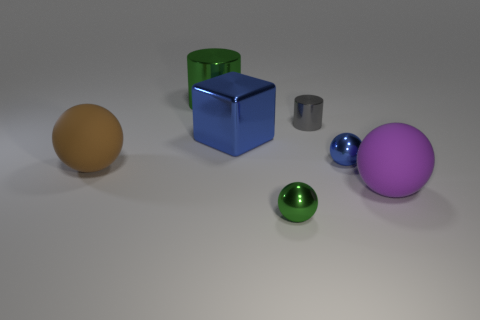What number of yellow objects are large cylinders or metal objects?
Provide a succinct answer. 0. Are there any green metal cylinders that have the same size as the brown sphere?
Offer a terse response. Yes. What number of big red metal objects are there?
Offer a terse response. 0. What number of large objects are blue cylinders or gray cylinders?
Provide a succinct answer. 0. There is a large matte thing that is on the right side of the blue object left of the blue object to the right of the green ball; what color is it?
Offer a terse response. Purple. How many other things are there of the same color as the large shiny cylinder?
Ensure brevity in your answer.  1. What number of shiny things are large balls or small cylinders?
Offer a very short reply. 1. There is a big matte sphere to the right of the large brown thing; does it have the same color as the ball left of the large cylinder?
Provide a succinct answer. No. Is there any other thing that is the same material as the large cylinder?
Make the answer very short. Yes. The purple matte object that is the same shape as the tiny blue metallic thing is what size?
Ensure brevity in your answer.  Large. 